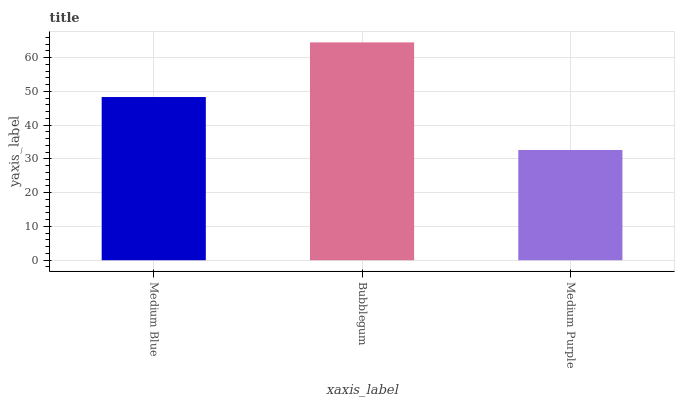Is Bubblegum the minimum?
Answer yes or no. No. Is Medium Purple the maximum?
Answer yes or no. No. Is Bubblegum greater than Medium Purple?
Answer yes or no. Yes. Is Medium Purple less than Bubblegum?
Answer yes or no. Yes. Is Medium Purple greater than Bubblegum?
Answer yes or no. No. Is Bubblegum less than Medium Purple?
Answer yes or no. No. Is Medium Blue the high median?
Answer yes or no. Yes. Is Medium Blue the low median?
Answer yes or no. Yes. Is Medium Purple the high median?
Answer yes or no. No. Is Bubblegum the low median?
Answer yes or no. No. 